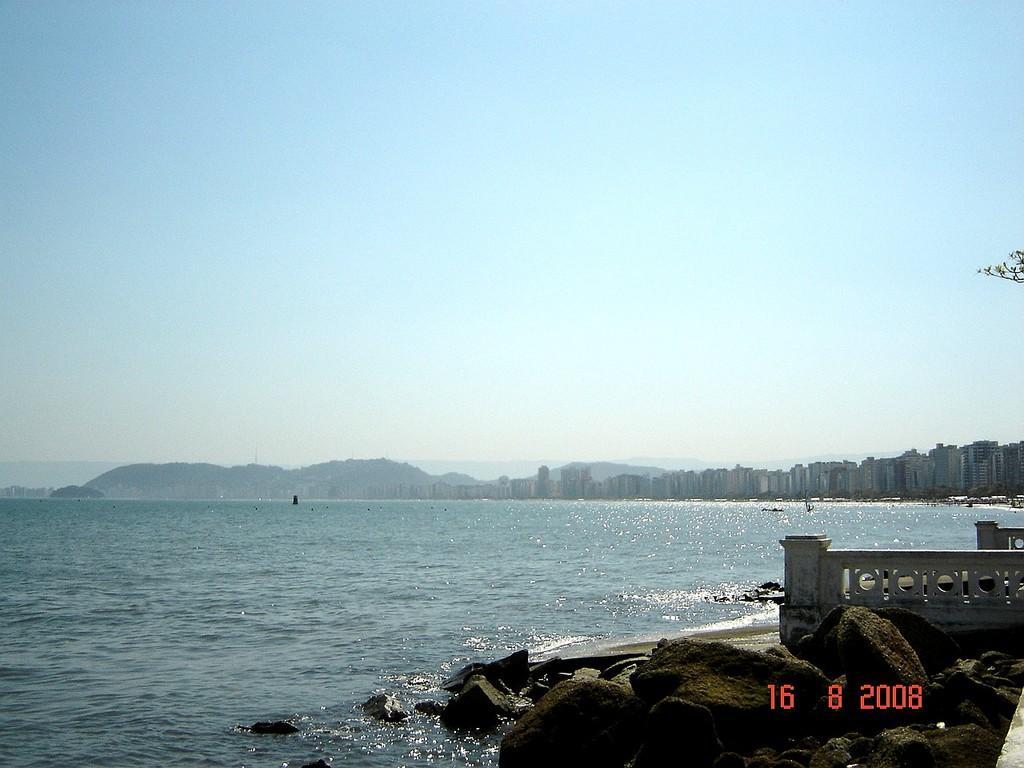Please provide a concise description of this image. In this image we can see the mountains, one lake, some objects on the ground, some buildings, two small walls with pillars, some rocks in the water, some objects on the ground, some leaves with stems on the right side of the image, some numbers on the bottom right side of the image and at the top there is the sky. 